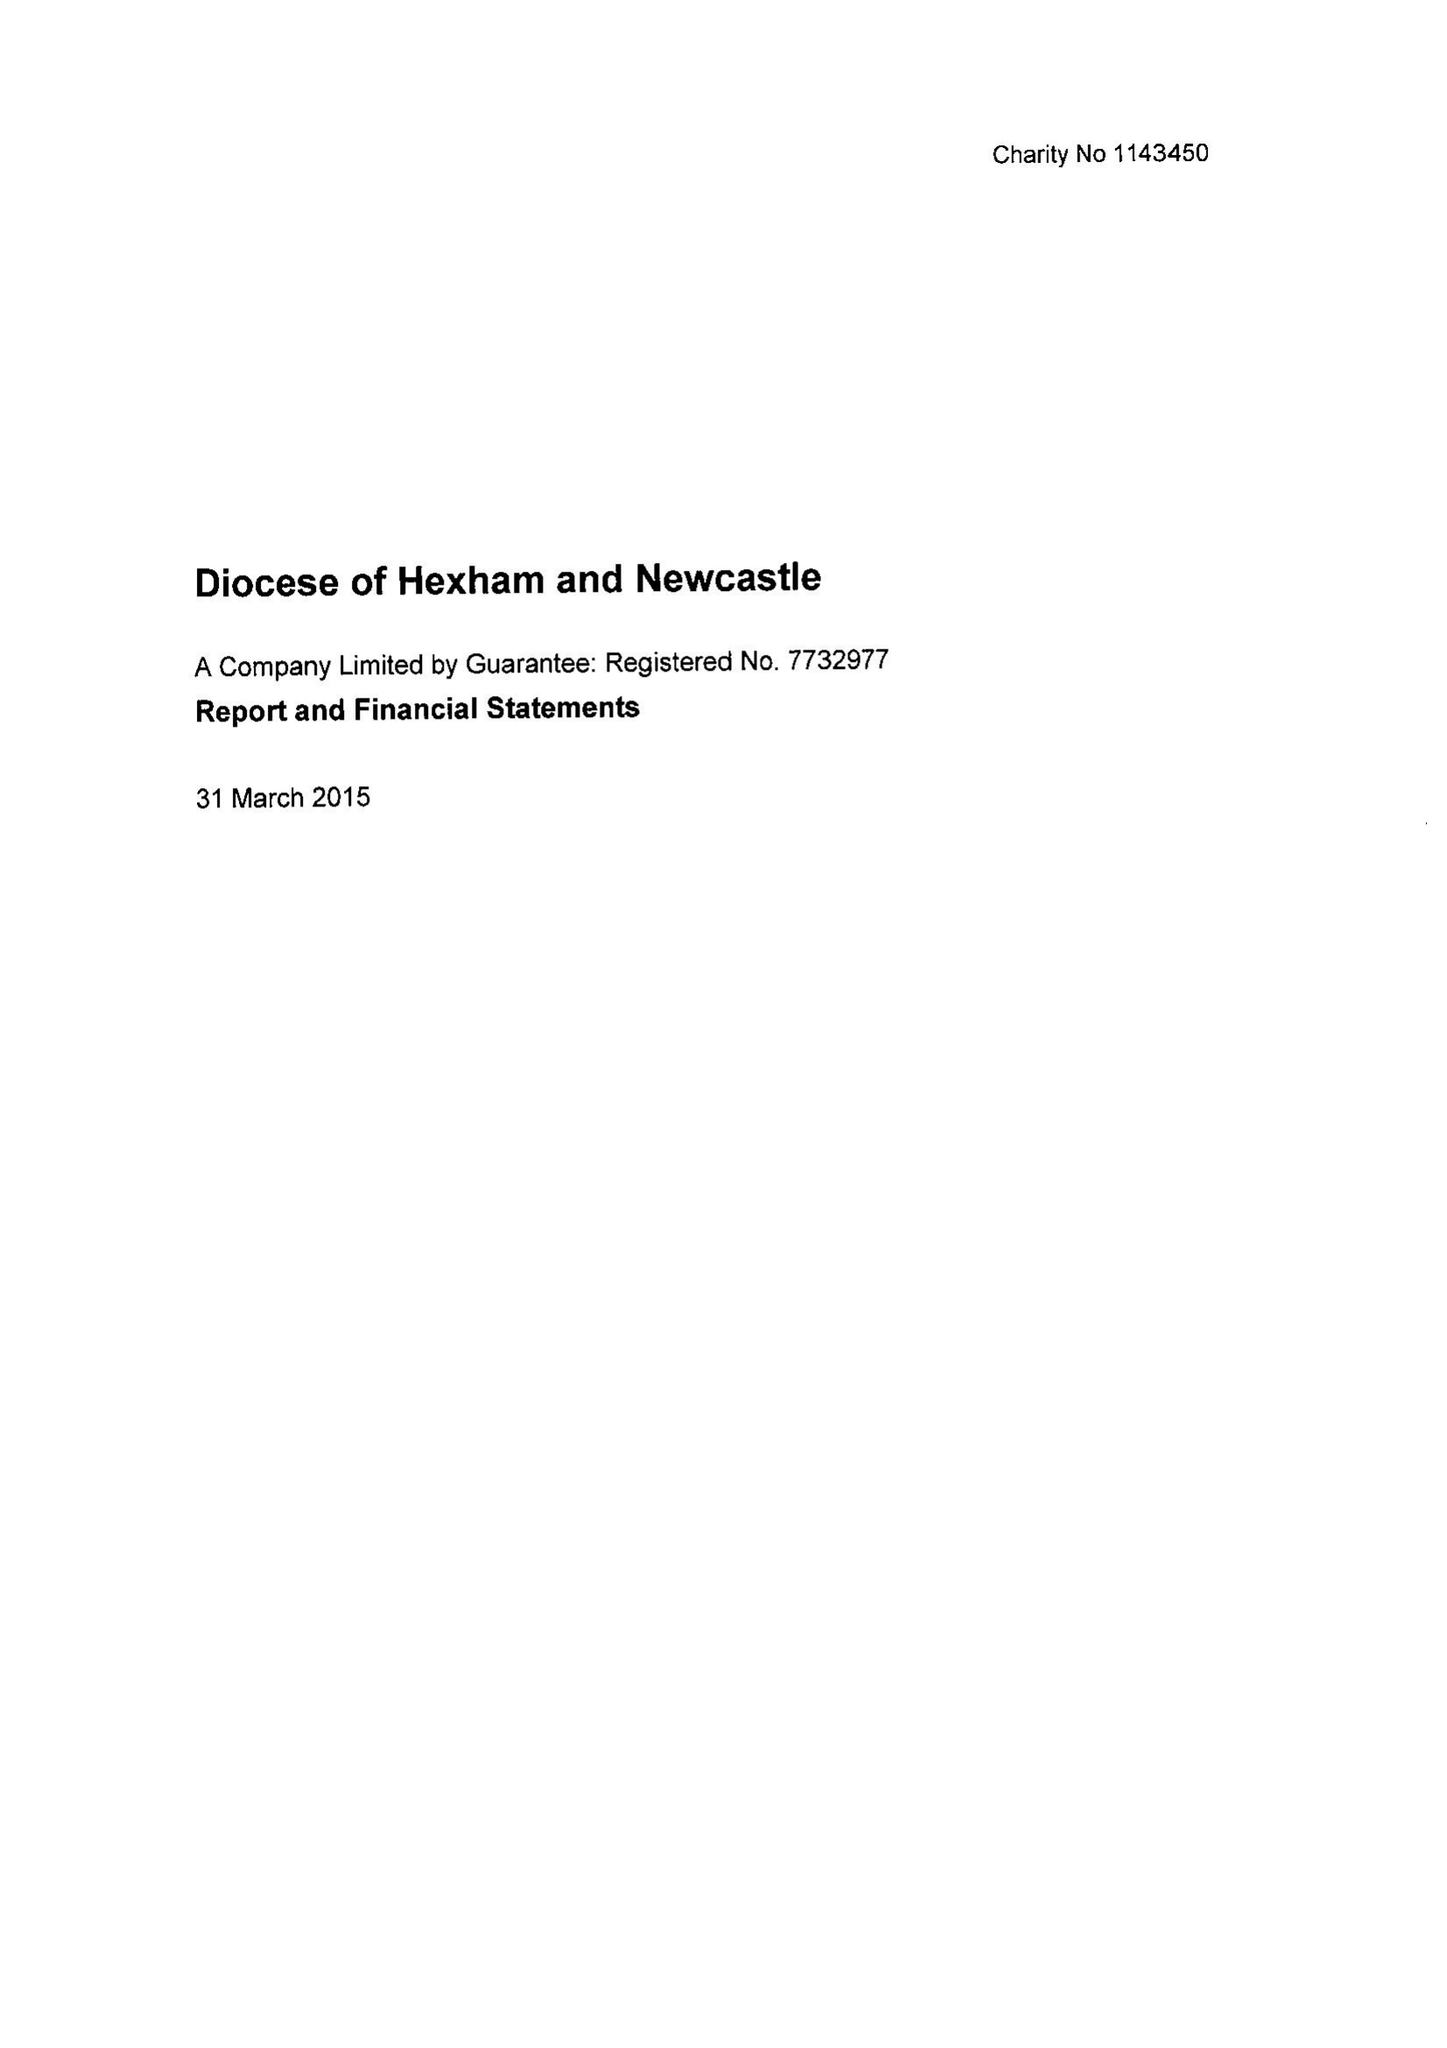What is the value for the spending_annually_in_british_pounds?
Answer the question using a single word or phrase. 20214535.00 